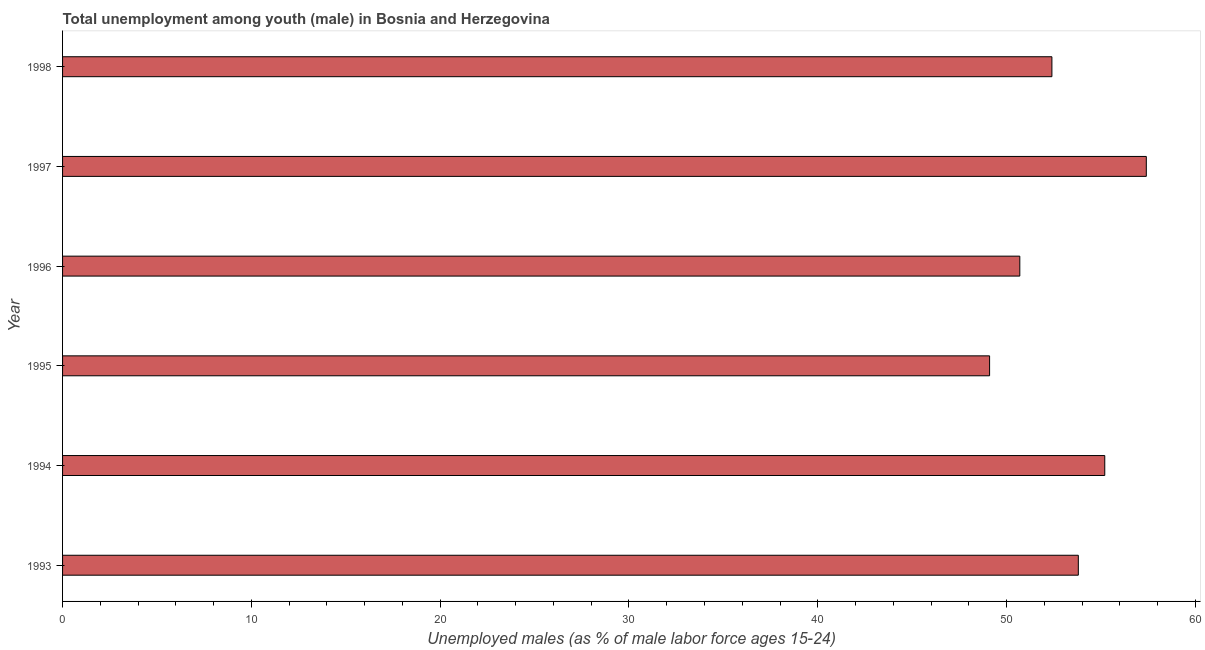Does the graph contain any zero values?
Your response must be concise. No. What is the title of the graph?
Offer a terse response. Total unemployment among youth (male) in Bosnia and Herzegovina. What is the label or title of the X-axis?
Keep it short and to the point. Unemployed males (as % of male labor force ages 15-24). What is the label or title of the Y-axis?
Ensure brevity in your answer.  Year. What is the unemployed male youth population in 1995?
Your response must be concise. 49.1. Across all years, what is the maximum unemployed male youth population?
Ensure brevity in your answer.  57.4. Across all years, what is the minimum unemployed male youth population?
Your response must be concise. 49.1. What is the sum of the unemployed male youth population?
Give a very brief answer. 318.6. What is the difference between the unemployed male youth population in 1995 and 1997?
Make the answer very short. -8.3. What is the average unemployed male youth population per year?
Offer a terse response. 53.1. What is the median unemployed male youth population?
Give a very brief answer. 53.1. Do a majority of the years between 1998 and 1996 (inclusive) have unemployed male youth population greater than 46 %?
Your answer should be compact. Yes. What is the ratio of the unemployed male youth population in 1994 to that in 1995?
Make the answer very short. 1.12. How many years are there in the graph?
Your response must be concise. 6. Are the values on the major ticks of X-axis written in scientific E-notation?
Ensure brevity in your answer.  No. What is the Unemployed males (as % of male labor force ages 15-24) in 1993?
Offer a very short reply. 53.8. What is the Unemployed males (as % of male labor force ages 15-24) in 1994?
Provide a succinct answer. 55.2. What is the Unemployed males (as % of male labor force ages 15-24) in 1995?
Give a very brief answer. 49.1. What is the Unemployed males (as % of male labor force ages 15-24) in 1996?
Provide a succinct answer. 50.7. What is the Unemployed males (as % of male labor force ages 15-24) in 1997?
Ensure brevity in your answer.  57.4. What is the Unemployed males (as % of male labor force ages 15-24) of 1998?
Offer a terse response. 52.4. What is the difference between the Unemployed males (as % of male labor force ages 15-24) in 1993 and 1994?
Make the answer very short. -1.4. What is the difference between the Unemployed males (as % of male labor force ages 15-24) in 1993 and 1996?
Provide a succinct answer. 3.1. What is the difference between the Unemployed males (as % of male labor force ages 15-24) in 1993 and 1997?
Ensure brevity in your answer.  -3.6. What is the difference between the Unemployed males (as % of male labor force ages 15-24) in 1993 and 1998?
Offer a terse response. 1.4. What is the difference between the Unemployed males (as % of male labor force ages 15-24) in 1994 and 1995?
Offer a very short reply. 6.1. What is the difference between the Unemployed males (as % of male labor force ages 15-24) in 1994 and 1996?
Your response must be concise. 4.5. What is the difference between the Unemployed males (as % of male labor force ages 15-24) in 1994 and 1997?
Your response must be concise. -2.2. What is the difference between the Unemployed males (as % of male labor force ages 15-24) in 1994 and 1998?
Make the answer very short. 2.8. What is the difference between the Unemployed males (as % of male labor force ages 15-24) in 1995 and 1998?
Ensure brevity in your answer.  -3.3. What is the difference between the Unemployed males (as % of male labor force ages 15-24) in 1996 and 1997?
Provide a short and direct response. -6.7. What is the difference between the Unemployed males (as % of male labor force ages 15-24) in 1996 and 1998?
Provide a short and direct response. -1.7. What is the ratio of the Unemployed males (as % of male labor force ages 15-24) in 1993 to that in 1994?
Your answer should be very brief. 0.97. What is the ratio of the Unemployed males (as % of male labor force ages 15-24) in 1993 to that in 1995?
Your response must be concise. 1.1. What is the ratio of the Unemployed males (as % of male labor force ages 15-24) in 1993 to that in 1996?
Ensure brevity in your answer.  1.06. What is the ratio of the Unemployed males (as % of male labor force ages 15-24) in 1993 to that in 1997?
Your answer should be compact. 0.94. What is the ratio of the Unemployed males (as % of male labor force ages 15-24) in 1993 to that in 1998?
Your answer should be compact. 1.03. What is the ratio of the Unemployed males (as % of male labor force ages 15-24) in 1994 to that in 1995?
Keep it short and to the point. 1.12. What is the ratio of the Unemployed males (as % of male labor force ages 15-24) in 1994 to that in 1996?
Your response must be concise. 1.09. What is the ratio of the Unemployed males (as % of male labor force ages 15-24) in 1994 to that in 1997?
Keep it short and to the point. 0.96. What is the ratio of the Unemployed males (as % of male labor force ages 15-24) in 1994 to that in 1998?
Ensure brevity in your answer.  1.05. What is the ratio of the Unemployed males (as % of male labor force ages 15-24) in 1995 to that in 1996?
Your answer should be compact. 0.97. What is the ratio of the Unemployed males (as % of male labor force ages 15-24) in 1995 to that in 1997?
Your answer should be very brief. 0.85. What is the ratio of the Unemployed males (as % of male labor force ages 15-24) in 1995 to that in 1998?
Your answer should be compact. 0.94. What is the ratio of the Unemployed males (as % of male labor force ages 15-24) in 1996 to that in 1997?
Your response must be concise. 0.88. What is the ratio of the Unemployed males (as % of male labor force ages 15-24) in 1996 to that in 1998?
Ensure brevity in your answer.  0.97. What is the ratio of the Unemployed males (as % of male labor force ages 15-24) in 1997 to that in 1998?
Ensure brevity in your answer.  1.09. 